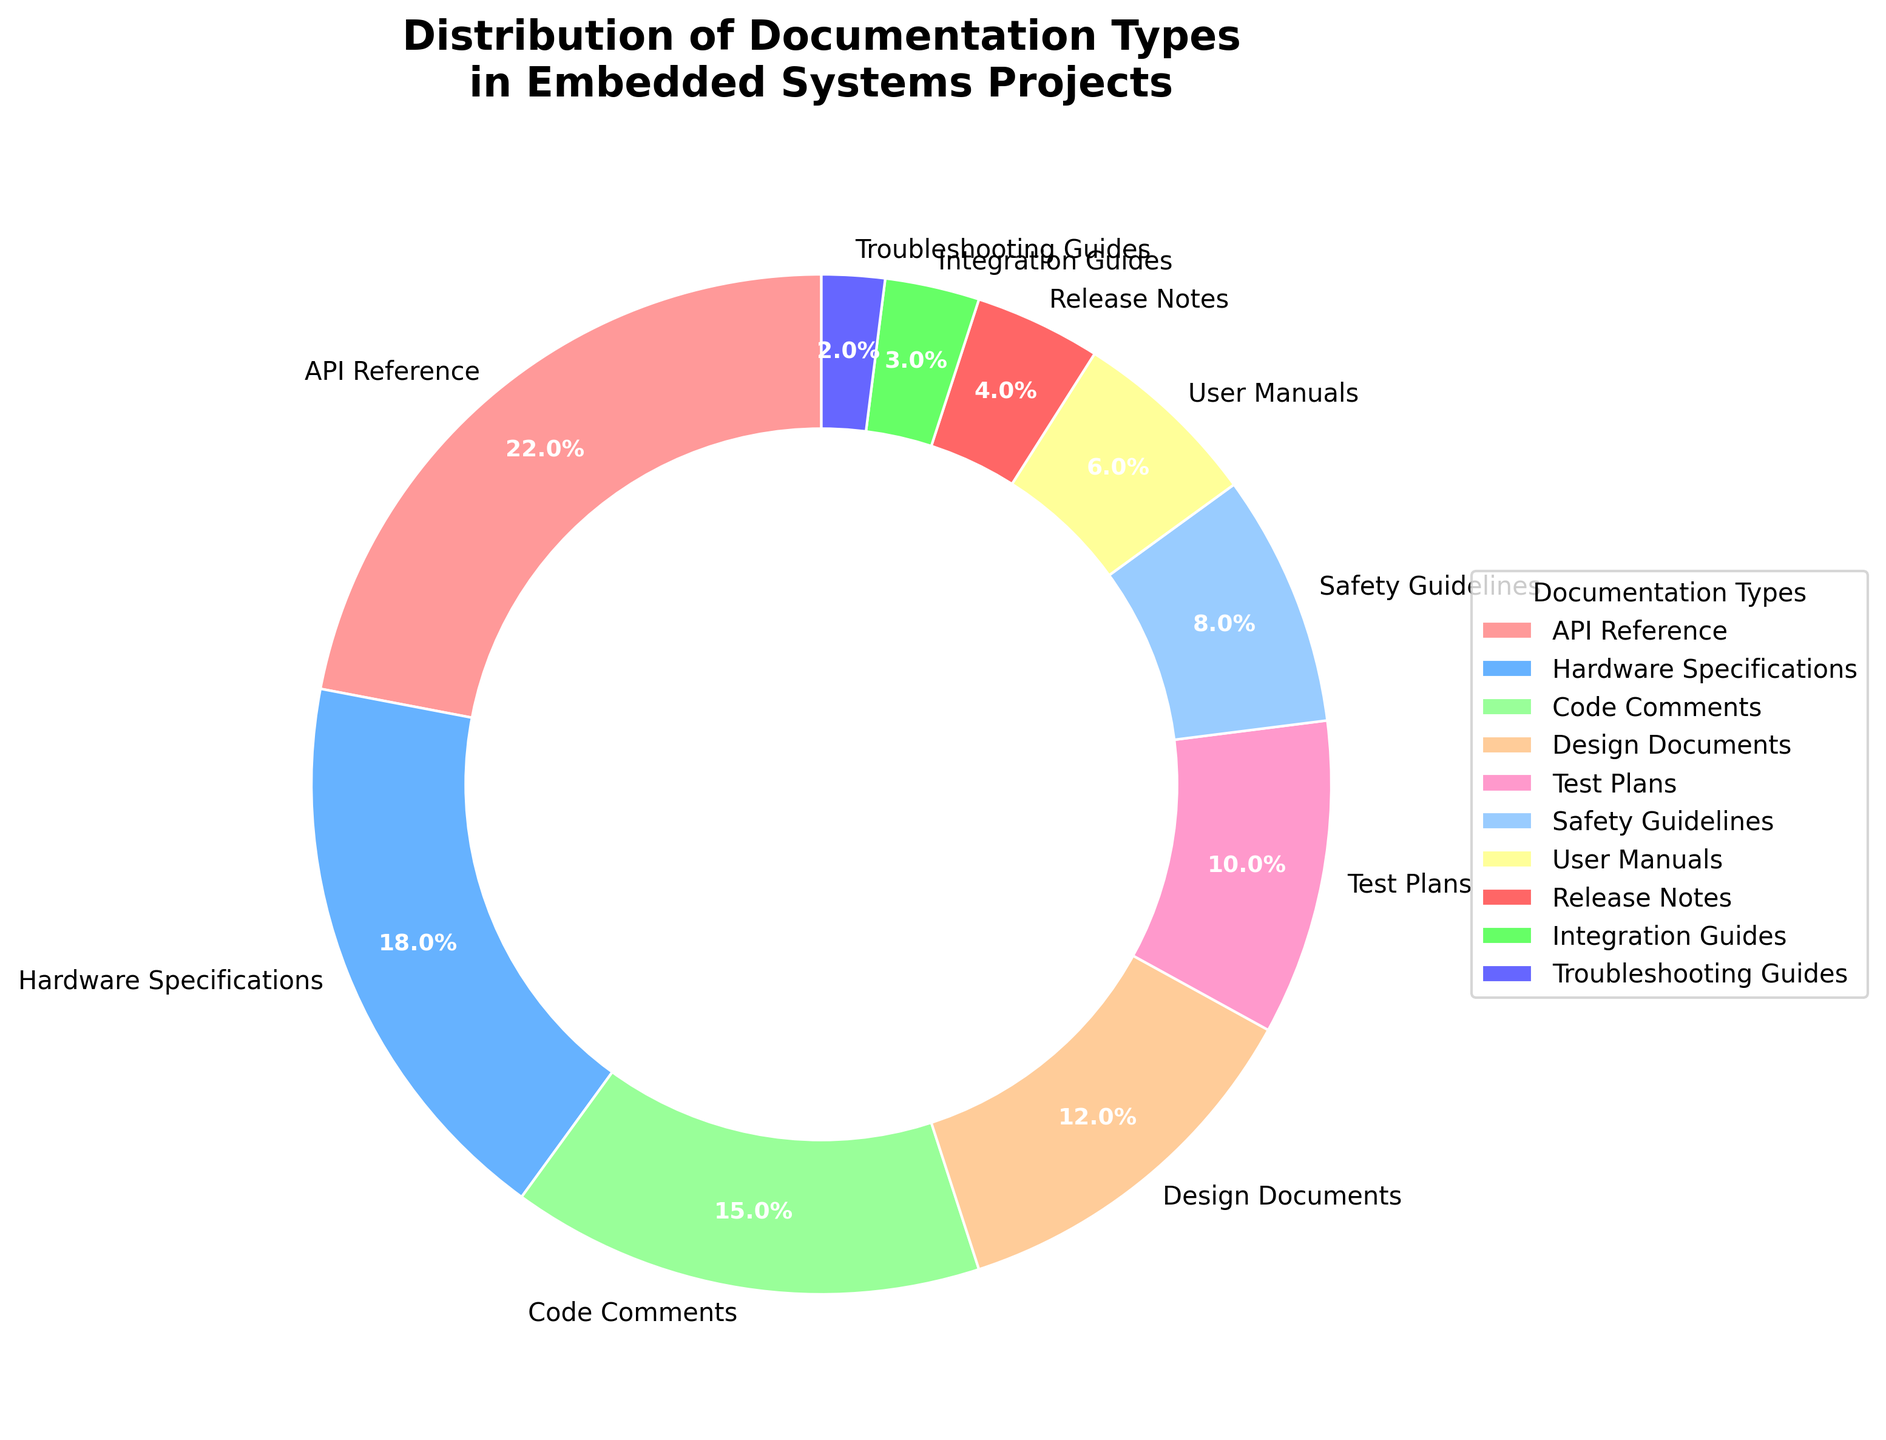What is the largest percentage documented type? The largest percentage can be identified by looking at which slice of the pie chart occupies the most area. The "API Reference" segment at 22% is the largest.
Answer: API Reference What is the combined percentage of "Design Documents" and "Test Plans"? Add the percentages of each segment: "Design Documents" (12%) and "Test Plans" (10%). 12 + 10 = 22%
Answer: 22% Which documentation type has the smallest percentage? The smallest segment in the pie chart represents the documentation type with the smallest percentage. The "Troubleshooting Guides" segment at 2% is the smallest.
Answer: Troubleshooting Guides How much larger is the "Hardware Specifications" percentage compared to the "Integration Guides" percentage? Subtract the percentage of "Integration Guides" from "Hardware Specifications". "Hardware Specifications" is 18% and "Integration Guides" is 3%. 18 - 3 = 15%
Answer: 15% What are the two documentation types with the closest percentages? Determine the absolute differences between the percentages of adjacent options and find the smallest. The "Safety Guidelines" at 8% and "User Manuals" at 6% have the closest values.
Answer: Safety Guidelines and User Manuals What is the cumulative percentage of the three smallest documentation types? Add the percentages of the three smallest segments: "Troubleshooting Guides" (2%), "Integration Guides" (3%), and "Release Notes" (4%). 2 + 3 + 4 = 9%
Answer: 9% Which documentation type represents approximately one-fifth of the overall project documentation? Identify the segment that is closest to 20%. The "API Reference" segment is at 22%, which is closest to one-fifth of the total.
Answer: API Reference Is the percentage of "Code Comments" higher or lower than that of "Design Documents" and "Test Plans" combined? The percentage of "Code Comments" is 15%. The combined percentage of "Design Documents" and "Test Plans" is 12% + 10% = 22%. Thus, "Code Comments" are lower.
Answer: Lower Which color is used to represent the "Release Notes"? Identify the color associated with the "Release Notes" segment in the pie chart. The "Release Notes" segment is colored in red.
Answer: Red What is the total percentage of documentation types that are less than 10% each? Add the percentages of segments less than 10%: "Safety Guidelines" (8%), "User Manuals" (6%), "Release Notes" (4%), "Integration Guides" (3%), "Troubleshooting Guides" (2%). 8 + 6 + 4 + 3 + 2 = 23%
Answer: 23% 